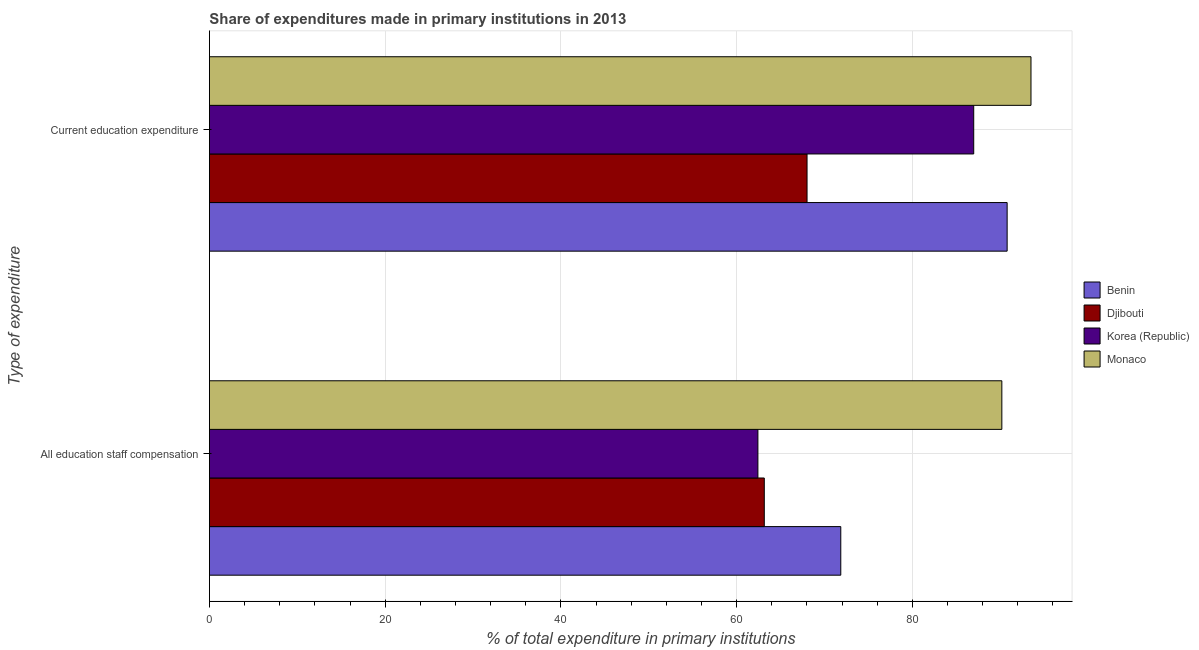How many different coloured bars are there?
Your answer should be compact. 4. What is the label of the 1st group of bars from the top?
Offer a terse response. Current education expenditure. What is the expenditure in staff compensation in Benin?
Your answer should be very brief. 71.85. Across all countries, what is the maximum expenditure in education?
Provide a short and direct response. 93.5. Across all countries, what is the minimum expenditure in education?
Your response must be concise. 68.01. In which country was the expenditure in staff compensation maximum?
Make the answer very short. Monaco. What is the total expenditure in education in the graph?
Provide a short and direct response. 339.28. What is the difference between the expenditure in staff compensation in Benin and that in Monaco?
Your answer should be compact. -18.33. What is the difference between the expenditure in education in Djibouti and the expenditure in staff compensation in Monaco?
Offer a very short reply. -22.17. What is the average expenditure in staff compensation per country?
Keep it short and to the point. 71.9. What is the difference between the expenditure in education and expenditure in staff compensation in Korea (Republic)?
Offer a very short reply. 24.56. What is the ratio of the expenditure in staff compensation in Korea (Republic) to that in Benin?
Offer a terse response. 0.87. Is the expenditure in education in Monaco less than that in Djibouti?
Your response must be concise. No. In how many countries, is the expenditure in education greater than the average expenditure in education taken over all countries?
Make the answer very short. 3. What does the 4th bar from the top in All education staff compensation represents?
Your response must be concise. Benin. What does the 2nd bar from the bottom in Current education expenditure represents?
Your answer should be compact. Djibouti. How many countries are there in the graph?
Keep it short and to the point. 4. What is the difference between two consecutive major ticks on the X-axis?
Give a very brief answer. 20. Are the values on the major ticks of X-axis written in scientific E-notation?
Give a very brief answer. No. How many legend labels are there?
Your response must be concise. 4. What is the title of the graph?
Provide a short and direct response. Share of expenditures made in primary institutions in 2013. What is the label or title of the X-axis?
Offer a very short reply. % of total expenditure in primary institutions. What is the label or title of the Y-axis?
Make the answer very short. Type of expenditure. What is the % of total expenditure in primary institutions in Benin in All education staff compensation?
Provide a short and direct response. 71.85. What is the % of total expenditure in primary institutions in Djibouti in All education staff compensation?
Provide a short and direct response. 63.15. What is the % of total expenditure in primary institutions in Korea (Republic) in All education staff compensation?
Keep it short and to the point. 62.42. What is the % of total expenditure in primary institutions of Monaco in All education staff compensation?
Ensure brevity in your answer.  90.18. What is the % of total expenditure in primary institutions in Benin in Current education expenditure?
Offer a terse response. 90.78. What is the % of total expenditure in primary institutions in Djibouti in Current education expenditure?
Give a very brief answer. 68.01. What is the % of total expenditure in primary institutions in Korea (Republic) in Current education expenditure?
Provide a succinct answer. 86.98. What is the % of total expenditure in primary institutions of Monaco in Current education expenditure?
Your answer should be very brief. 93.5. Across all Type of expenditure, what is the maximum % of total expenditure in primary institutions of Benin?
Provide a short and direct response. 90.78. Across all Type of expenditure, what is the maximum % of total expenditure in primary institutions in Djibouti?
Offer a terse response. 68.01. Across all Type of expenditure, what is the maximum % of total expenditure in primary institutions in Korea (Republic)?
Keep it short and to the point. 86.98. Across all Type of expenditure, what is the maximum % of total expenditure in primary institutions of Monaco?
Offer a very short reply. 93.5. Across all Type of expenditure, what is the minimum % of total expenditure in primary institutions of Benin?
Your answer should be compact. 71.85. Across all Type of expenditure, what is the minimum % of total expenditure in primary institutions in Djibouti?
Make the answer very short. 63.15. Across all Type of expenditure, what is the minimum % of total expenditure in primary institutions of Korea (Republic)?
Provide a short and direct response. 62.42. Across all Type of expenditure, what is the minimum % of total expenditure in primary institutions in Monaco?
Your answer should be compact. 90.18. What is the total % of total expenditure in primary institutions of Benin in the graph?
Your answer should be compact. 162.64. What is the total % of total expenditure in primary institutions of Djibouti in the graph?
Offer a terse response. 131.16. What is the total % of total expenditure in primary institutions of Korea (Republic) in the graph?
Your answer should be very brief. 149.4. What is the total % of total expenditure in primary institutions of Monaco in the graph?
Provide a succinct answer. 183.68. What is the difference between the % of total expenditure in primary institutions of Benin in All education staff compensation and that in Current education expenditure?
Provide a short and direct response. -18.93. What is the difference between the % of total expenditure in primary institutions of Djibouti in All education staff compensation and that in Current education expenditure?
Your answer should be compact. -4.87. What is the difference between the % of total expenditure in primary institutions of Korea (Republic) in All education staff compensation and that in Current education expenditure?
Offer a very short reply. -24.56. What is the difference between the % of total expenditure in primary institutions of Monaco in All education staff compensation and that in Current education expenditure?
Offer a very short reply. -3.32. What is the difference between the % of total expenditure in primary institutions of Benin in All education staff compensation and the % of total expenditure in primary institutions of Djibouti in Current education expenditure?
Provide a short and direct response. 3.84. What is the difference between the % of total expenditure in primary institutions in Benin in All education staff compensation and the % of total expenditure in primary institutions in Korea (Republic) in Current education expenditure?
Your answer should be very brief. -15.13. What is the difference between the % of total expenditure in primary institutions of Benin in All education staff compensation and the % of total expenditure in primary institutions of Monaco in Current education expenditure?
Your answer should be compact. -21.65. What is the difference between the % of total expenditure in primary institutions in Djibouti in All education staff compensation and the % of total expenditure in primary institutions in Korea (Republic) in Current education expenditure?
Give a very brief answer. -23.83. What is the difference between the % of total expenditure in primary institutions of Djibouti in All education staff compensation and the % of total expenditure in primary institutions of Monaco in Current education expenditure?
Give a very brief answer. -30.35. What is the difference between the % of total expenditure in primary institutions of Korea (Republic) in All education staff compensation and the % of total expenditure in primary institutions of Monaco in Current education expenditure?
Your response must be concise. -31.08. What is the average % of total expenditure in primary institutions in Benin per Type of expenditure?
Your response must be concise. 81.32. What is the average % of total expenditure in primary institutions of Djibouti per Type of expenditure?
Your response must be concise. 65.58. What is the average % of total expenditure in primary institutions in Korea (Republic) per Type of expenditure?
Your answer should be very brief. 74.7. What is the average % of total expenditure in primary institutions in Monaco per Type of expenditure?
Provide a short and direct response. 91.84. What is the difference between the % of total expenditure in primary institutions of Benin and % of total expenditure in primary institutions of Djibouti in All education staff compensation?
Keep it short and to the point. 8.7. What is the difference between the % of total expenditure in primary institutions of Benin and % of total expenditure in primary institutions of Korea (Republic) in All education staff compensation?
Provide a short and direct response. 9.43. What is the difference between the % of total expenditure in primary institutions in Benin and % of total expenditure in primary institutions in Monaco in All education staff compensation?
Offer a very short reply. -18.33. What is the difference between the % of total expenditure in primary institutions in Djibouti and % of total expenditure in primary institutions in Korea (Republic) in All education staff compensation?
Your response must be concise. 0.73. What is the difference between the % of total expenditure in primary institutions of Djibouti and % of total expenditure in primary institutions of Monaco in All education staff compensation?
Keep it short and to the point. -27.04. What is the difference between the % of total expenditure in primary institutions in Korea (Republic) and % of total expenditure in primary institutions in Monaco in All education staff compensation?
Your response must be concise. -27.76. What is the difference between the % of total expenditure in primary institutions in Benin and % of total expenditure in primary institutions in Djibouti in Current education expenditure?
Give a very brief answer. 22.77. What is the difference between the % of total expenditure in primary institutions in Benin and % of total expenditure in primary institutions in Korea (Republic) in Current education expenditure?
Give a very brief answer. 3.8. What is the difference between the % of total expenditure in primary institutions in Benin and % of total expenditure in primary institutions in Monaco in Current education expenditure?
Offer a very short reply. -2.71. What is the difference between the % of total expenditure in primary institutions in Djibouti and % of total expenditure in primary institutions in Korea (Republic) in Current education expenditure?
Your answer should be compact. -18.97. What is the difference between the % of total expenditure in primary institutions in Djibouti and % of total expenditure in primary institutions in Monaco in Current education expenditure?
Your answer should be very brief. -25.49. What is the difference between the % of total expenditure in primary institutions of Korea (Republic) and % of total expenditure in primary institutions of Monaco in Current education expenditure?
Provide a short and direct response. -6.52. What is the ratio of the % of total expenditure in primary institutions of Benin in All education staff compensation to that in Current education expenditure?
Give a very brief answer. 0.79. What is the ratio of the % of total expenditure in primary institutions in Djibouti in All education staff compensation to that in Current education expenditure?
Your response must be concise. 0.93. What is the ratio of the % of total expenditure in primary institutions of Korea (Republic) in All education staff compensation to that in Current education expenditure?
Your response must be concise. 0.72. What is the ratio of the % of total expenditure in primary institutions of Monaco in All education staff compensation to that in Current education expenditure?
Give a very brief answer. 0.96. What is the difference between the highest and the second highest % of total expenditure in primary institutions of Benin?
Offer a terse response. 18.93. What is the difference between the highest and the second highest % of total expenditure in primary institutions of Djibouti?
Your response must be concise. 4.87. What is the difference between the highest and the second highest % of total expenditure in primary institutions of Korea (Republic)?
Your answer should be very brief. 24.56. What is the difference between the highest and the second highest % of total expenditure in primary institutions in Monaco?
Provide a succinct answer. 3.32. What is the difference between the highest and the lowest % of total expenditure in primary institutions in Benin?
Ensure brevity in your answer.  18.93. What is the difference between the highest and the lowest % of total expenditure in primary institutions in Djibouti?
Make the answer very short. 4.87. What is the difference between the highest and the lowest % of total expenditure in primary institutions in Korea (Republic)?
Your answer should be compact. 24.56. What is the difference between the highest and the lowest % of total expenditure in primary institutions in Monaco?
Offer a very short reply. 3.32. 